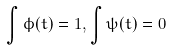<formula> <loc_0><loc_0><loc_500><loc_500>\int \phi ( t ) = 1 , \int \psi ( t ) = 0</formula> 